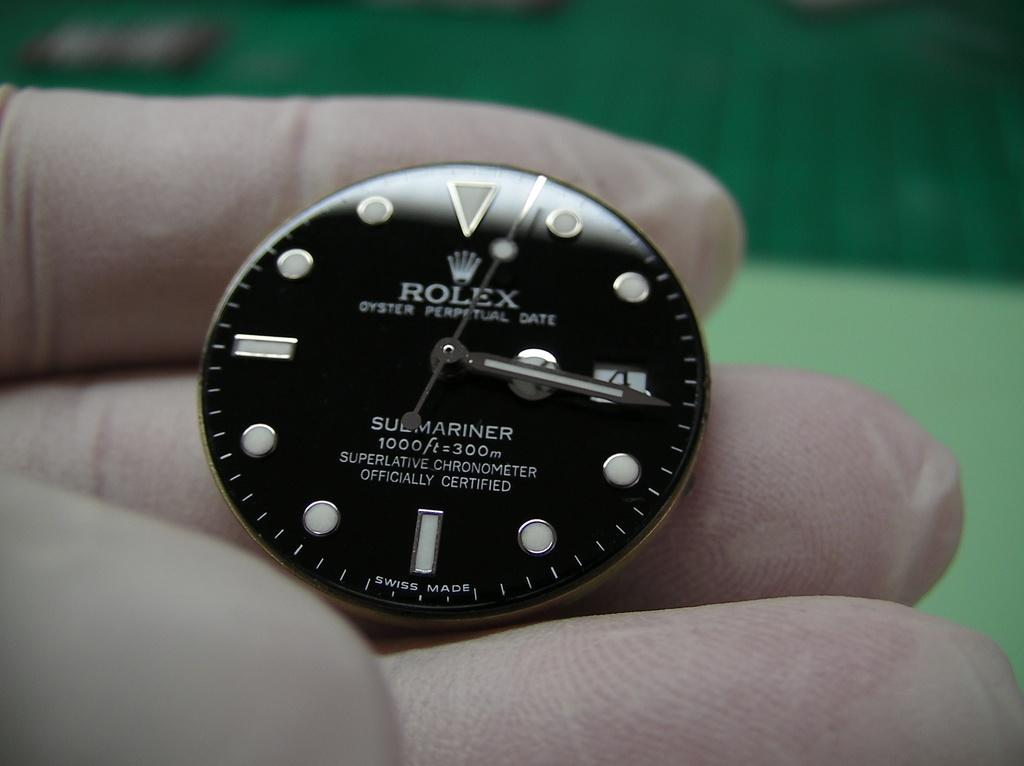<image>
Share a concise interpretation of the image provided. Someone is holding a Rolex watch face that is from a submariner watch. 